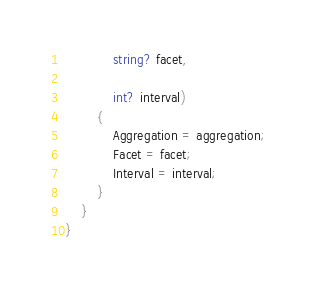<code> <loc_0><loc_0><loc_500><loc_500><_C#_>
            string? facet,

            int? interval)
        {
            Aggregation = aggregation;
            Facet = facet;
            Interval = interval;
        }
    }
}
</code> 